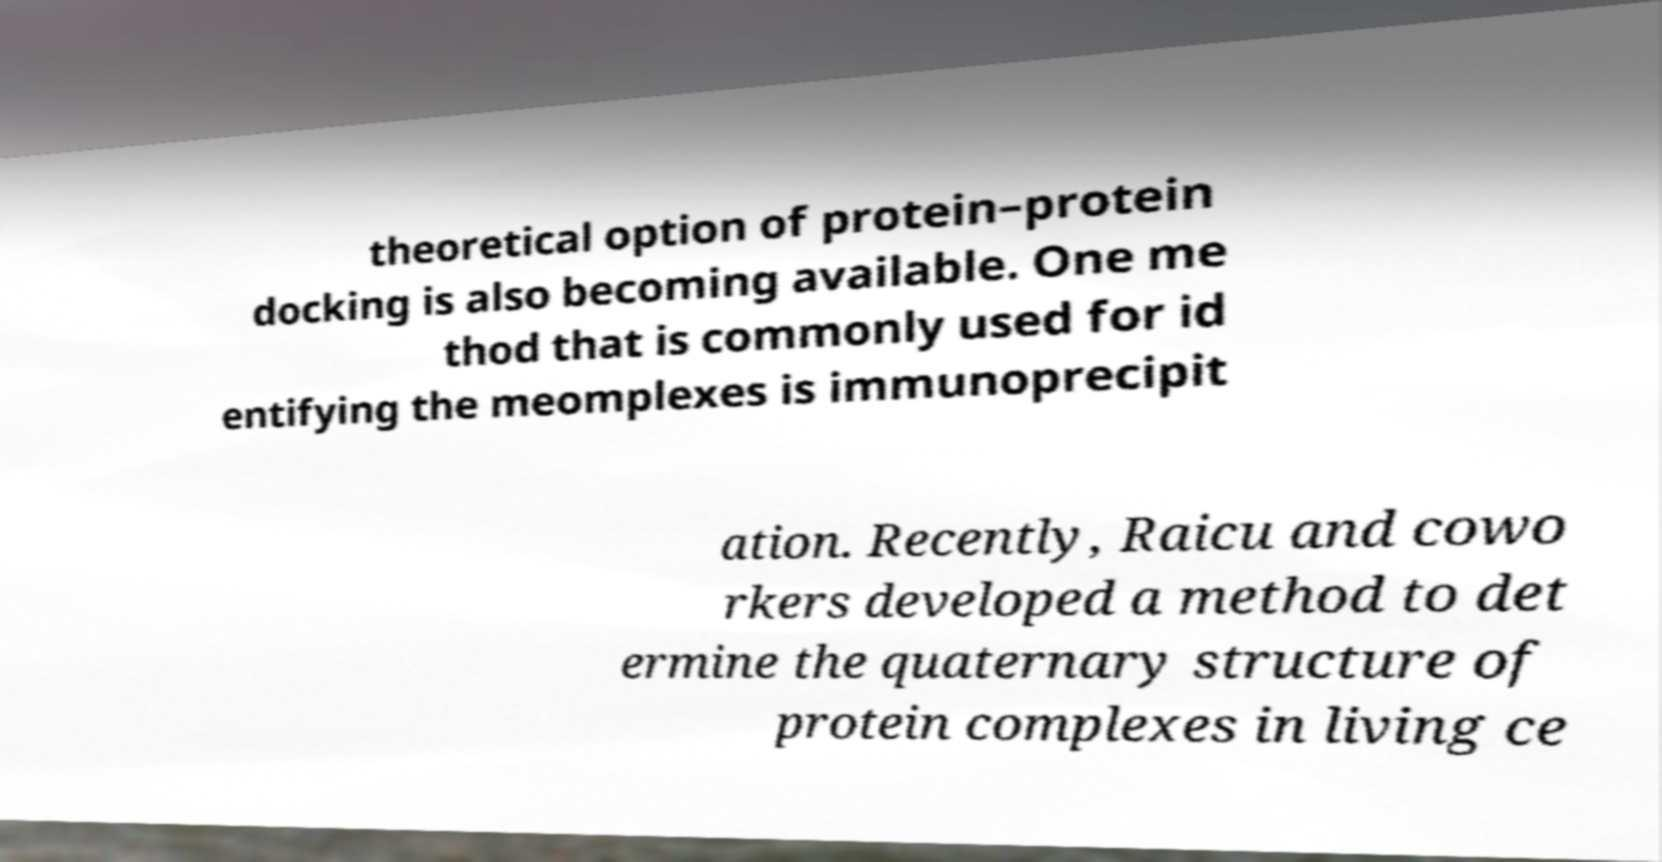Could you assist in decoding the text presented in this image and type it out clearly? theoretical option of protein–protein docking is also becoming available. One me thod that is commonly used for id entifying the meomplexes is immunoprecipit ation. Recently, Raicu and cowo rkers developed a method to det ermine the quaternary structure of protein complexes in living ce 